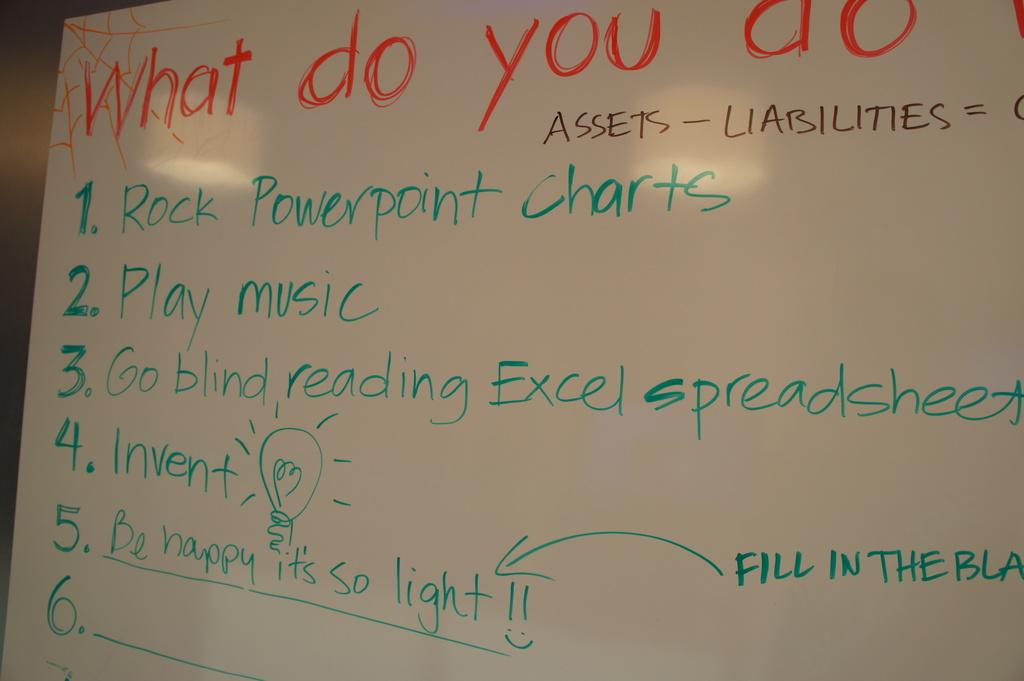<image>
Render a clear and concise summary of the photo. a white board with the world What do you do at the top. 